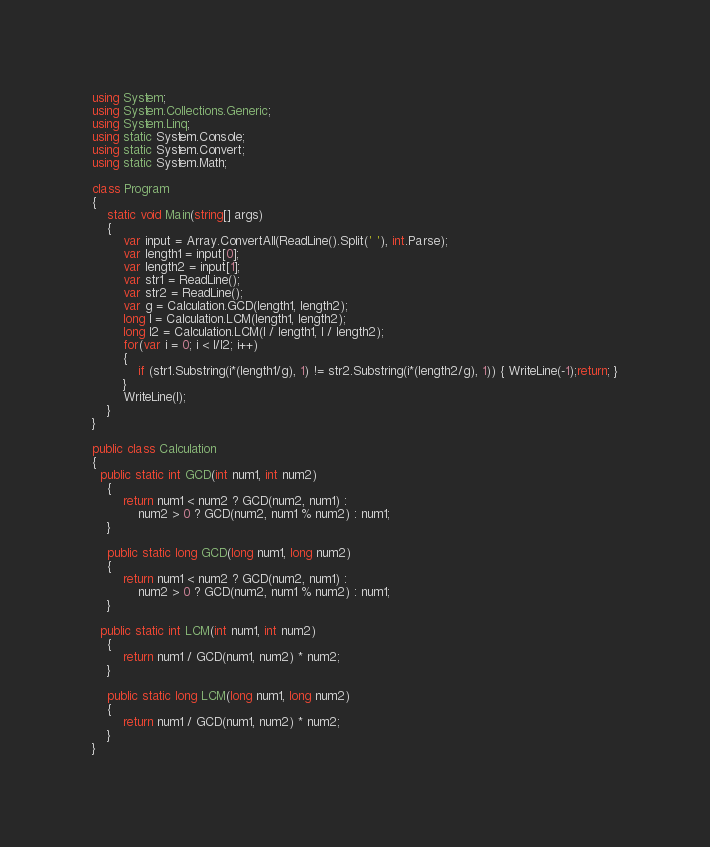Convert code to text. <code><loc_0><loc_0><loc_500><loc_500><_C#_>using System;
using System.Collections.Generic;
using System.Linq;
using static System.Console;
using static System.Convert;
using static System.Math;
 
class Program
{
    static void Main(string[] args)
    {
        var input = Array.ConvertAll(ReadLine().Split(' '), int.Parse);
        var length1 = input[0];
        var length2 = input[1];
        var str1 = ReadLine();
        var str2 = ReadLine();
        var g = Calculation.GCD(length1, length2);
        long l = Calculation.LCM(length1, length2);
        long l2 = Calculation.LCM(l / length1, l / length2);
        for(var i = 0; i < l/l2; i++)
        {
            if (str1.Substring(i*(length1/g), 1) != str2.Substring(i*(length2/g), 1)) { WriteLine(-1);return; }
        }
        WriteLine(l);
    }
}
 
public class Calculation
{
  public static int GCD(int num1, int num2)
    {
        return num1 < num2 ? GCD(num2, num1) :
            num2 > 0 ? GCD(num2, num1 % num2) : num1;
    }
 
    public static long GCD(long num1, long num2)
    {
        return num1 < num2 ? GCD(num2, num1) :
            num2 > 0 ? GCD(num2, num1 % num2) : num1;
    }
  
  public static int LCM(int num1, int num2)
    {
        return num1 / GCD(num1, num2) * num2;
    }
 
    public static long LCM(long num1, long num2)
    {
        return num1 / GCD(num1, num2) * num2;
    }
}</code> 